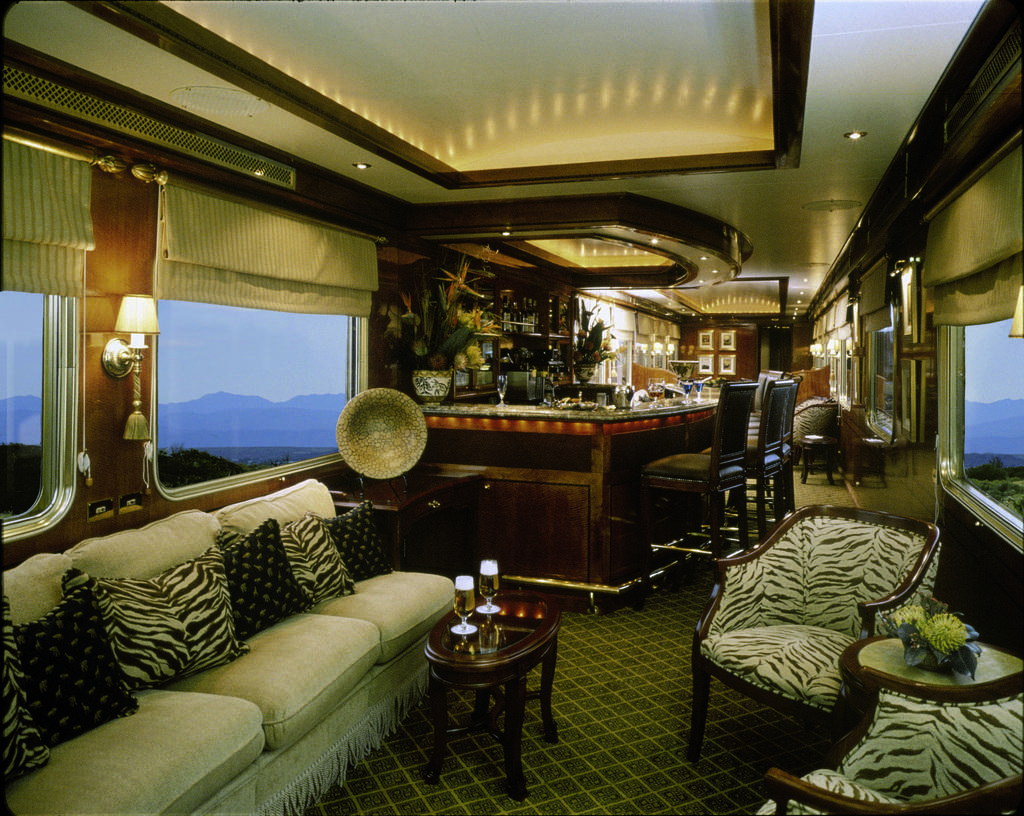Please provide a concise description of this image. The picture is taken in a room. In the foreground of the picture there are couches, pillows, tables, flower vase, glasses, drink. On the right, there are curtain, window, frames and lights in the ceiling, outside the window there are trees and hills. On the left there are windows, curtains, lamp and lights, outside the window there are hills. In the center of the background there are chairs, music instrument, desk, glasses, bottles, lights, frames, many other objects. 